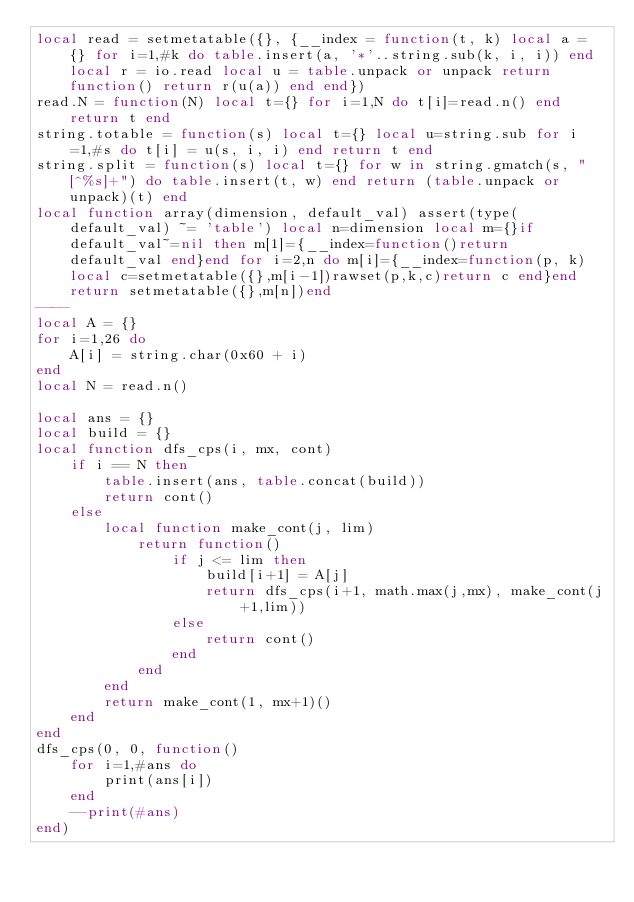Convert code to text. <code><loc_0><loc_0><loc_500><loc_500><_Lua_>local read = setmetatable({}, {__index = function(t, k) local a = {} for i=1,#k do table.insert(a, '*'..string.sub(k, i, i)) end local r = io.read local u = table.unpack or unpack return function() return r(u(a)) end end})
read.N = function(N) local t={} for i=1,N do t[i]=read.n() end return t end
string.totable = function(s) local t={} local u=string.sub for i=1,#s do t[i] = u(s, i, i) end return t end
string.split = function(s) local t={} for w in string.gmatch(s, "[^%s]+") do table.insert(t, w) end return (table.unpack or unpack)(t) end
local function array(dimension, default_val) assert(type(default_val) ~= 'table') local n=dimension local m={}if default_val~=nil then m[1]={__index=function()return default_val end}end for i=2,n do m[i]={__index=function(p, k)local c=setmetatable({},m[i-1])rawset(p,k,c)return c end}end return setmetatable({},m[n])end
----
local A = {}
for i=1,26 do
    A[i] = string.char(0x60 + i)
end
local N = read.n()

local ans = {}
local build = {}
local function dfs_cps(i, mx, cont)
    if i == N then
        table.insert(ans, table.concat(build))
        return cont()
    else
        local function make_cont(j, lim)
            return function()
                if j <= lim then
                    build[i+1] = A[j]
                    return dfs_cps(i+1, math.max(j,mx), make_cont(j+1,lim))
                else
                    return cont()
                end
            end
        end
        return make_cont(1, mx+1)()
    end
end
dfs_cps(0, 0, function()
    for i=1,#ans do
        print(ans[i])
    end
    --print(#ans)
end)</code> 